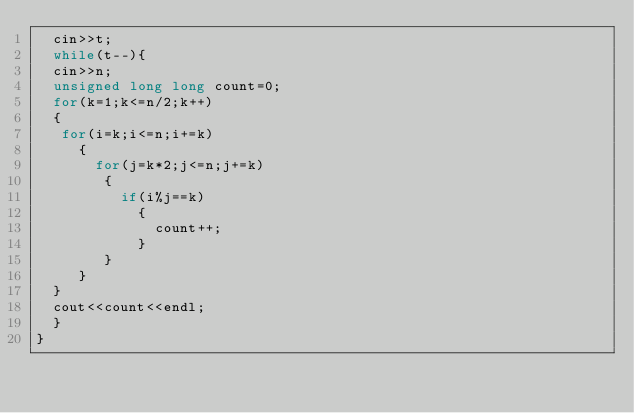<code> <loc_0><loc_0><loc_500><loc_500><_C++_>  cin>>t;
  while(t--){
  cin>>n;
  unsigned long long count=0;
  for(k=1;k<=n/2;k++)
  {
   for(i=k;i<=n;i+=k)
     {
       for(j=k*2;j<=n;j+=k)
        {
          if(i%j==k)
            {
              count++;
            }
        }
     }
  }
  cout<<count<<endl;
  }
}
</code> 